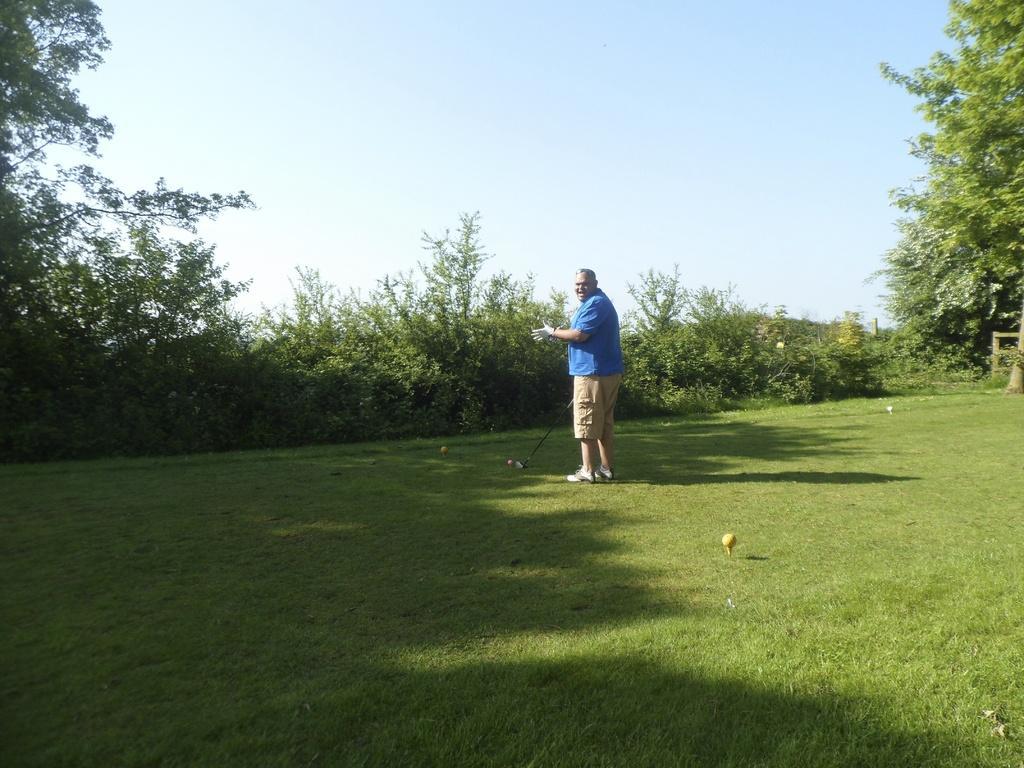How would you summarize this image in a sentence or two? In the image there is a man standing on the ground he is playing golf game,there are a lot of trees and plants around the man. 